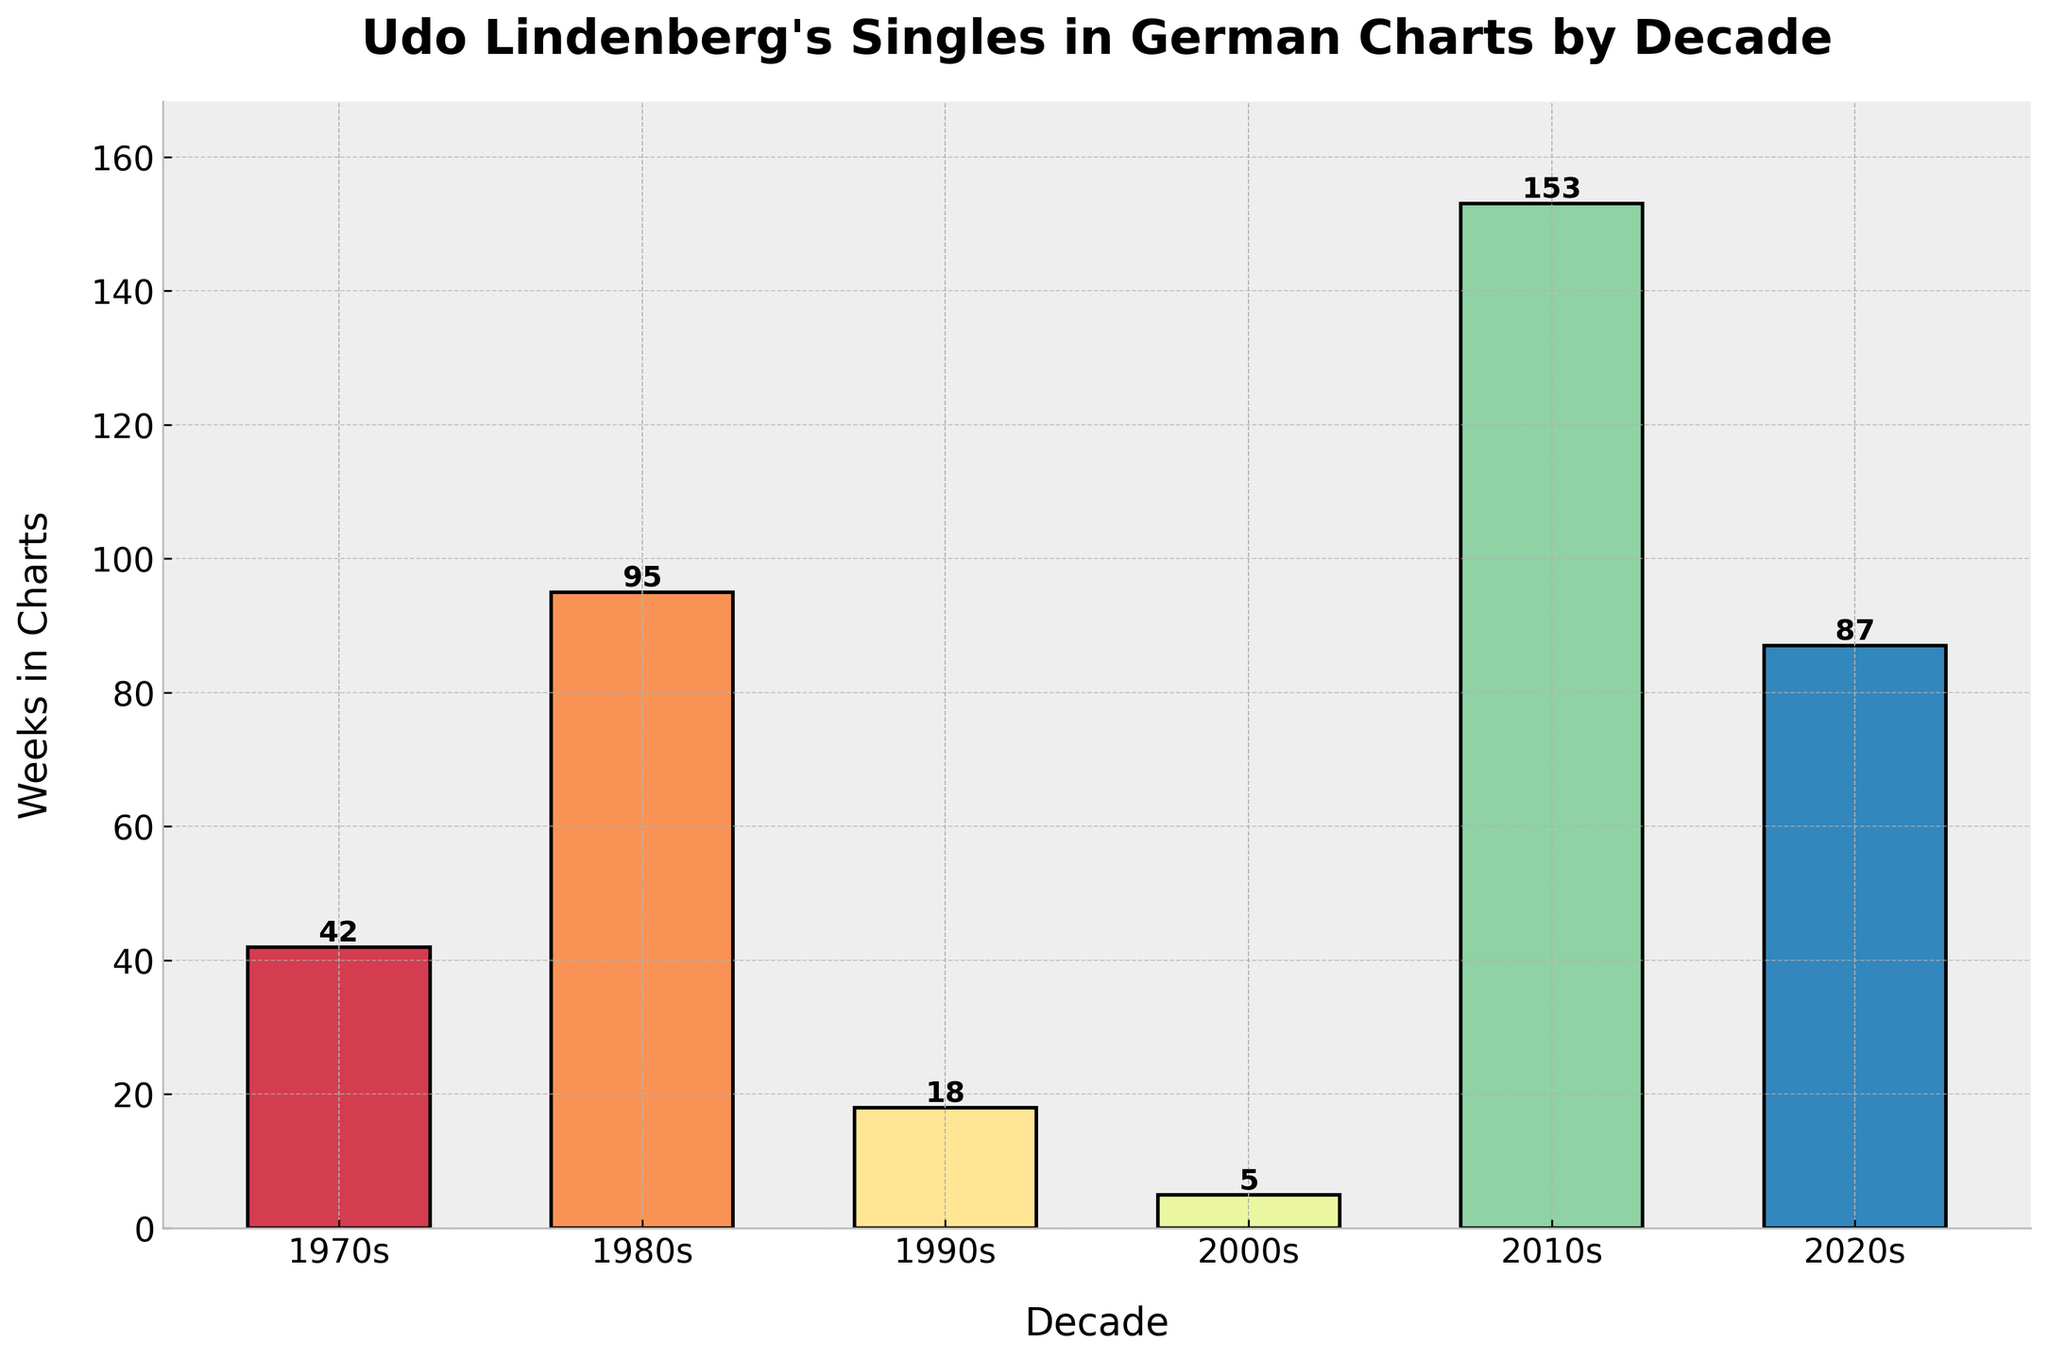What decade did Udo Lindenberg's singles spend the most weeks in the German charts? First, scan through the bar heights on the chart for each decade. The highest bar corresponds to the 2010s.
Answer: 2010s How many more weeks did Udo Lindenberg's singles spend in the charts during the 2010s compared to the 2000s? Identify and subtract the heights of the bars for the 2000s (5 weeks) from the 2010s (153 weeks). Calculation: 153 - 5 = 148.
Answer: 148 What is the total number of weeks Udo Lindenberg's singles spent in the charts from the 1980s to the 2020s? Sum the weeks from the decades of 1980s (95 weeks), 1990s (18 weeks), 2000s (5 weeks), 2010s (153 weeks), and 2020s (87 weeks). Calculation: 95 + 18 + 5 + 153 + 87 = 358.
Answer: 358 How does the number of weeks in the charts in the 2020s compare to the 1990s? Compare the height of bars for the 2020s (87 weeks) and 1990s (18 weeks). The 2020s are higher.
Answer: 2020s spent more Which decade saw a decline in the number of weeks from the previous decade's count? Check the sequence of bar heights. The 1990s (18 weeks) are less than the 1980s (95 weeks), and the 2000s (5 weeks) are less than the 1990s.
Answer: 1990s and 2000s What is the average number of weeks Udo Lindenberg's singles spent in the charts per decade? Sum the total weeks for all decades and divide by the number of decades. Calculation: (42 + 95 + 18 + 5 + 153 + 87) / 6 = 400 / 6 ≈ 66.67
Answer: 66.67 Which decade had the least number of weeks Udo Lindenberg's singles were in the charts? Identify the shortest bar in the chart, which is for the 2000s with 5 weeks.
Answer: 2000s How many total weeks did Udo Lindenberg's singles spend in the charts during the last two decades (2010s and 2020s)? Add the weeks from the 2010s (153 weeks) and the 2020s (87 weeks). Calculation: 153 + 87 = 240.
Answer: 240 What is the difference in the number of weeks Udo Lindenberg's singles spent in the charts between the 1970s and the 2020s? Subtract the 1970s (42 weeks) from the 2020s (87 weeks). Calculation: 87 - 42 = 45.
Answer: 45 